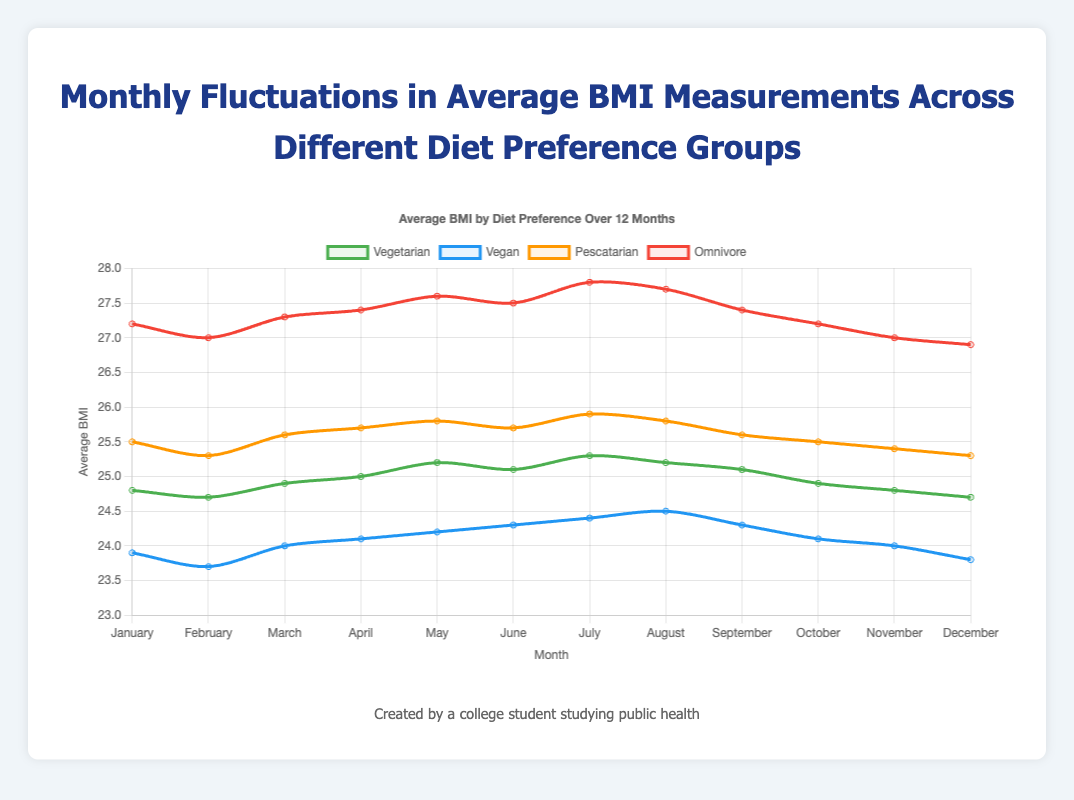Which diet preference group had the highest BMI in January? Look at the data points for January across all groups. Omnivore has the highest value at 27.2.
Answer: Omnivore During which month did the vegan group's BMI reach its highest value? Review the data points for the vegan group each month. The highest BMI is 24.5, which occurs in August.
Answer: August What is the difference in BMI between the vegetarian and omnivore groups in July? For July, subtract the vegetarian BMI from the omnivore BMI: 27.8 - 25.3 = 2.5.
Answer: 2.5 In which month did the pescatarian group's BMI increase significantly from the previous month? Focus on the pescatarian data and find the largest increase. The biggest jump occurs from June (25.7) to July (25.9), an increase of 0.2.
Answer: June to July Is there a clear trend in the BMI measurements for the vegan group over the months? Examine the vegan group's data points from January to December. The BMI generally increases from January (23.9) to August (24.5) and decreases towards December (23.8).
Answer: Yes, a rise and then a fall How many times did the vegetarian group's BMI change compared to the previous month? Track the changes for the vegetarian group BMI from January to December. Changes occur between each month.
Answer: 11 Which diet preference group has the most stable BMI measurements over the year? Compare the variability in BMIs across all groups. The vegan group shows the smallest range from 23.7 to 24.5.
Answer: Vegan By how much did the omnivore group's BMI decrease from April to December? Subtract the December value from April's for omnivore: 27.4 - 26.9 = 0.5.
Answer: 0.5 During which months is the BMI for all diet preference groups the closest? Look for time points where the values for all groups converge. In December, the values are 24.7 (vegetarian), 23.8 (vegan), 25.3 (pescatarian), and 26.9 (omnivore), which are quite close compared to other months.
Answer: December What is the average BMI for the pescatarian group over the year? Sum the pescatarian group's monthly values and divide by 12: (25.5 + 25.3 + 25.6 + 25.7 + 25.8 + 25.7 + 25.9 + 25.8 + 25.6 + 25.5 + 25.4 + 25.3) / 12 = 25.6.
Answer: 25.6 